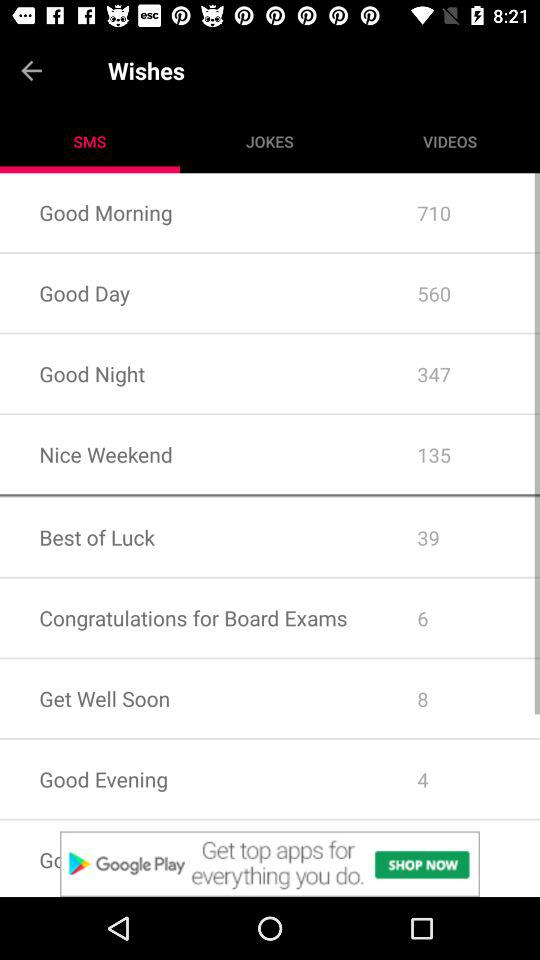How many wishes are there in total?
Answer the question using a single word or phrase. 8 